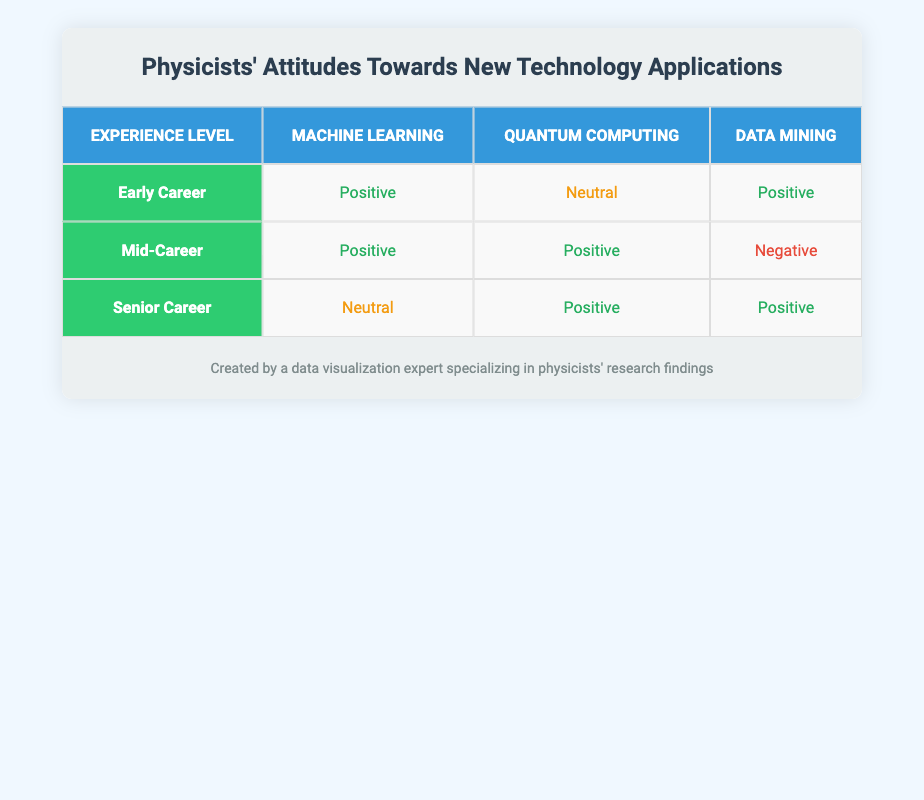What is the attitude of Early Career physicists towards Machine Learning? The table shows that Early Career physicists have a "Positive" attitude towards Machine Learning. This can be found in the row corresponding to Early Career and the column for Machine Learning.
Answer: Positive How many technology applications have Senior Career physicists rated as Positive? In the table, Senior Career physicists rated two technology applications (Quantum Computing and Data Mining) as Positive. You can find these in the corresponding row and columns.
Answer: 2 Is there a technology application that is rated as Negative by any physicist? Yes, the table indicates that Data Mining is rated as Negative by Mid-Career physicists. This can be identified in the Mid-Career row and the Data Mining column.
Answer: Yes What is the overall attitude of Mid-Career physicists towards Quantum Computing? The table shows that Mid-Career physicists have a "Positive" attitude towards Quantum Computing. This information is located in the Mid-Career row and the Quantum Computing column.
Answer: Positive How does the attitude towards Data Mining compare between Early Career and Mid-Career physicists? Early Career physicists rated Data Mining as "Positive," while Mid-Career physicists rated it as "Negative." Thus, there is a difference in attitudes, with Early Career physicists being positive and Mid-Career physicists being negative.
Answer: Early Career: Positive; Mid-Career: Negative What proportion of technology applications has a Neutral attitude among the Senior Career physicists? Out of the three technology applications (Machine Learning, Quantum Computing, and Data Mining), only Machine Learning is rated as Neutral, giving a proportion of 1/3 or approximately 33.33%.
Answer: 33.33% Which physicist experience level has the most Positive attitudes overall? The Mid-Career physicists have three total technology applications rated, two of which are Positive (Machine Learning and Quantum Computing). In contrast, Early Career has two Positive ratings, and Senior Career has two as well. Overall, Early Career and Senior Career have the same number of positive ratings as Mid-Career's total but with fewer positive attitudes combined.
Answer: Mid-Career What is the difference in attitudes toward Machine Learning between Early Career and Senior Career physicists? Early Career physicists rated Machine Learning as "Positive," while Senior Career physicists rated it as "Neutral." The difference indicates that Early Career physicists have a more favorable view of this technology application compared to Senior Career physicists.
Answer: Positive for Early Career; Neutral for Senior Career Which technology application is most favored by the physicists based on their attitude ratings? Data Mining and Quantum Computing are both rated as Positive by Early Career physicists and Senior Career physicists, while only Quantum Computing is rated Positive by Mid-Career physicists. Overall, Quantum Computing appears most favored with consistently positive attitudes combined across experience levels.
Answer: Quantum Computing How many total Negative attitudes are present in the table across all experience levels? The only Negative attitude present is from Mid-Career physicists toward Data Mining. Other categories can be compared to find no extra negatives. Thus, the total is 1.
Answer: 1 